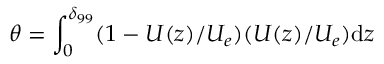<formula> <loc_0><loc_0><loc_500><loc_500>\theta = \int _ { 0 } ^ { \delta _ { 9 9 } } ( 1 - U ( z ) / U _ { e } ) ( U ( z ) / U _ { e } ) d z</formula> 